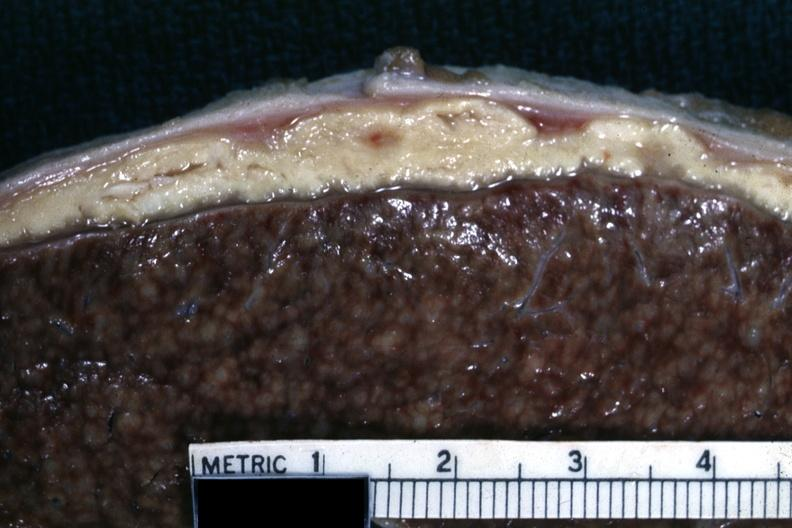what is present?
Answer the question using a single word or phrase. Abdomen 